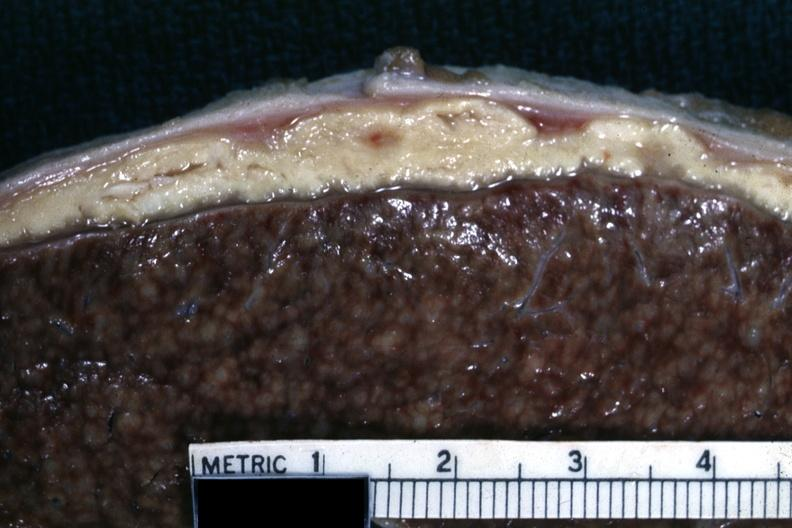what is present?
Answer the question using a single word or phrase. Abdomen 